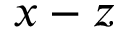<formula> <loc_0><loc_0><loc_500><loc_500>x - z</formula> 